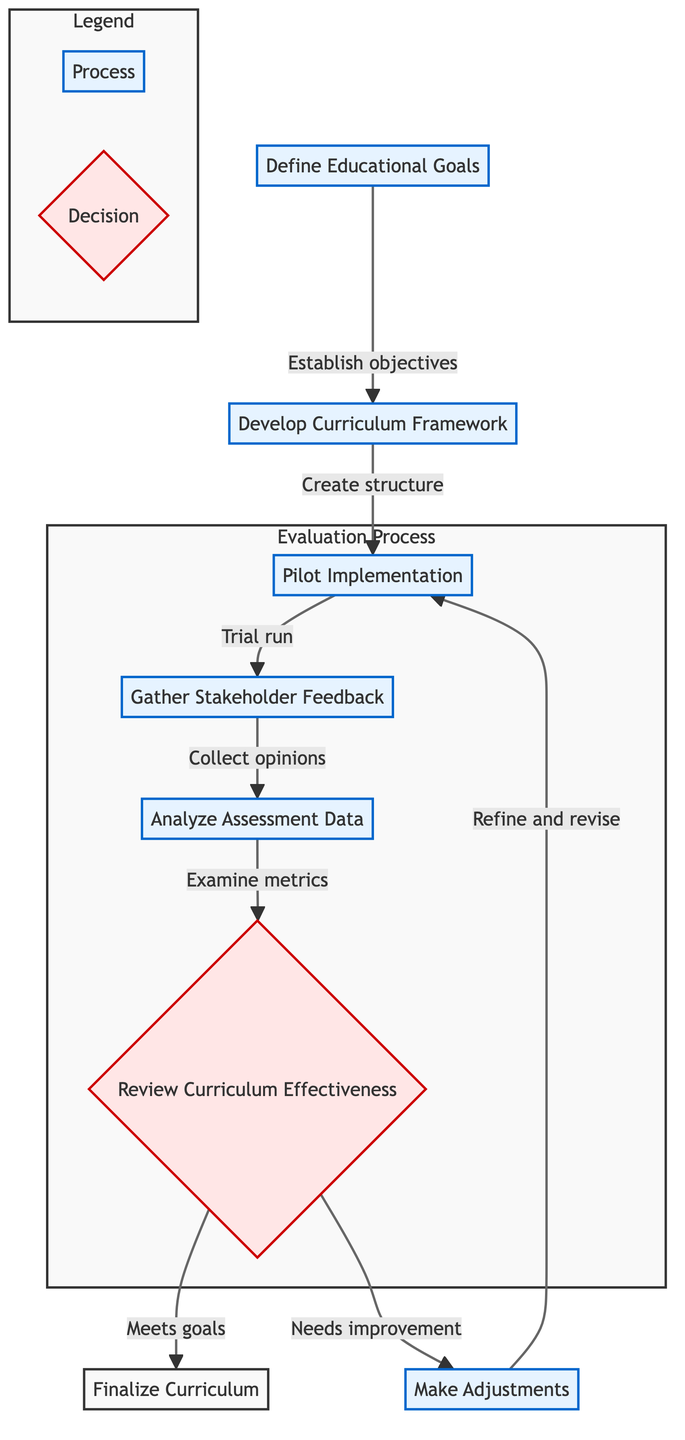What is the first step in the evaluation process? The first step in the evaluation process, as indicated in the flowchart, is "Define Educational Goals." This is the starting point before any further actions can be taken.
Answer: Define Educational Goals How many major steps are involved in the flowchart? By counting the distinct elements in the flowchart, there are a total of seven major steps outlined. This includes all processes and the decision point.
Answer: Seven What does the final outcome of the review step depend on? The final outcome from the review step ("Review Curriculum Effectiveness") depends on whether the curriculum meets the predefined educational goals, as indicated by the two possible outputs stemming from this decision node.
Answer: Predefined educational goals Which step follows the "Pilot Implementation" step? The step that follows "Pilot Implementation" in the flowchart is "Gather Stakeholder Feedback." This indicates that after testing the curriculum, it is essential to collect feedback from those involved.
Answer: Gather Stakeholder Feedback What happens if the curriculum needs improvement after the review? If the curriculum needs improvement after the review, the flowchart indicates that adjustments will be made, which involves refining and revising the curriculum, and then it will return to "Pilot Implementation" for further testing.
Answer: Make Adjustments Which node indicates a decision to be made in the process? The node that indicates a decision point in the process is "Review Curriculum Effectiveness." This is where an evaluation must be made to determine the next course of action regarding the curriculum.
Answer: Review Curriculum Effectiveness What is collected during the "Gather Stakeholder Feedback" step? During the "Gather Stakeholder Feedback" step, opinions and evaluations from various stakeholders, including teachers, students, parents, and administrators, are collected to assess the effectiveness of the new curriculum.
Answer: Opinions and evaluations What connects the "Analyze Assessment Data" step to the decision node? The connection that links "Analyze Assessment Data" to the decision node "Review Curriculum Effectiveness" is through the analysis of performance metrics and test scores, which are crucial for making the evaluation.
Answer: Examine metrics 